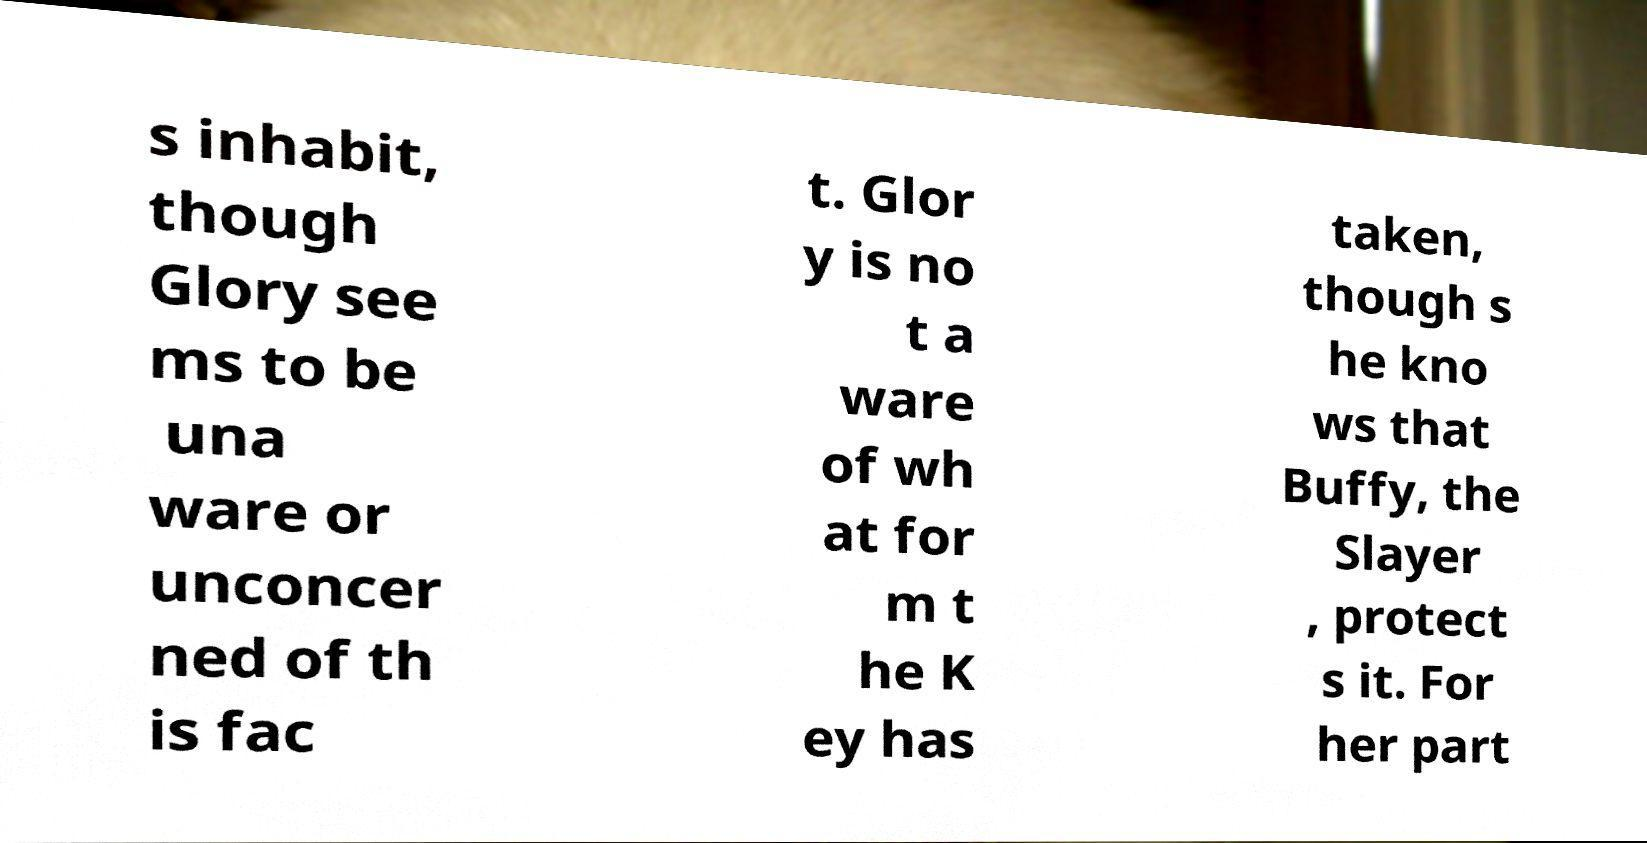What messages or text are displayed in this image? I need them in a readable, typed format. s inhabit, though Glory see ms to be una ware or unconcer ned of th is fac t. Glor y is no t a ware of wh at for m t he K ey has taken, though s he kno ws that Buffy, the Slayer , protect s it. For her part 